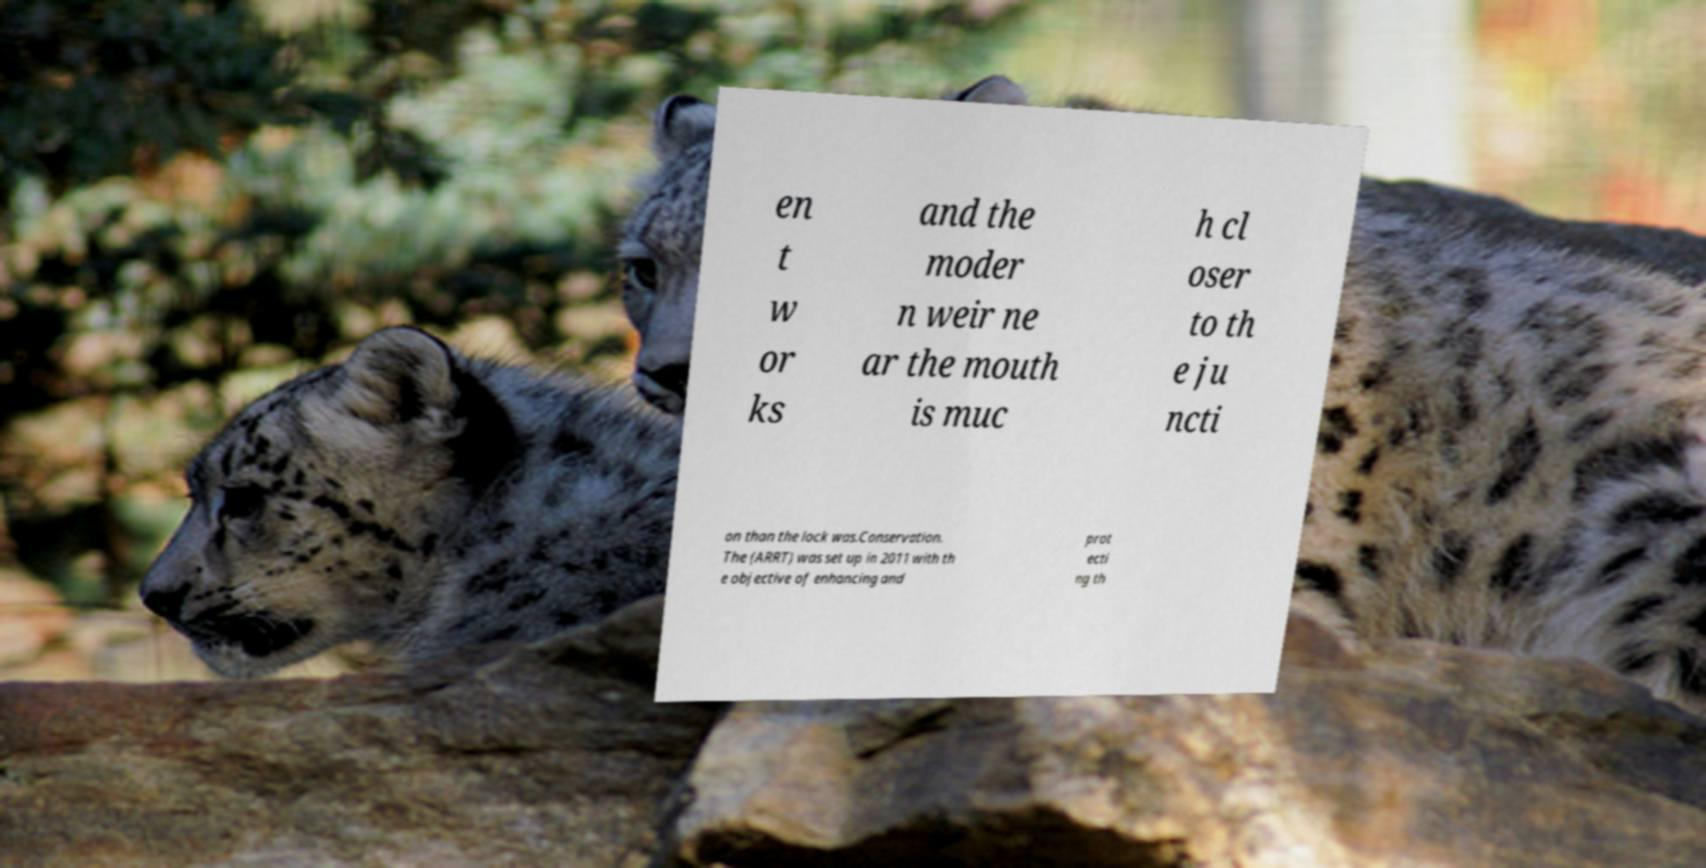I need the written content from this picture converted into text. Can you do that? en t w or ks and the moder n weir ne ar the mouth is muc h cl oser to th e ju ncti on than the lock was.Conservation. The (ARRT) was set up in 2011 with th e objective of enhancing and prot ecti ng th 